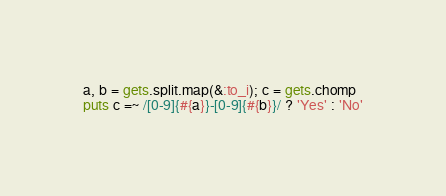<code> <loc_0><loc_0><loc_500><loc_500><_Ruby_>a, b = gets.split.map(&:to_i); c = gets.chomp
puts c =~ /[0-9]{#{a}}-[0-9]{#{b}}/ ? 'Yes' : 'No'</code> 